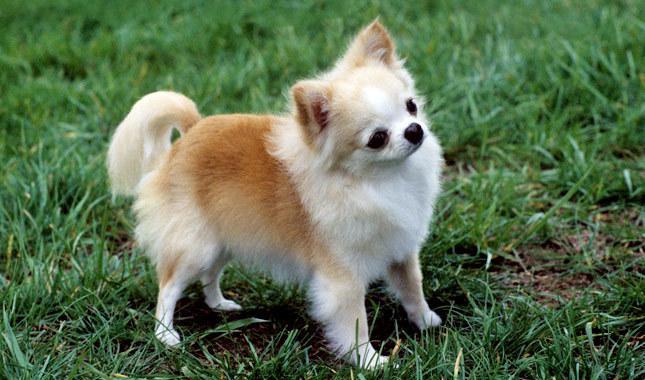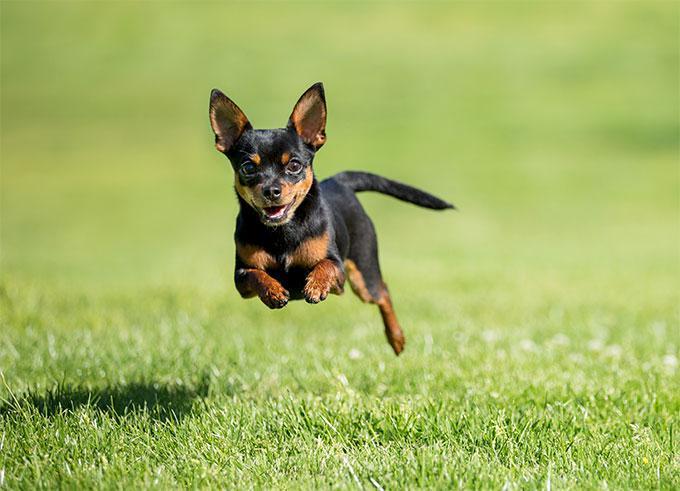The first image is the image on the left, the second image is the image on the right. Assess this claim about the two images: "the dog on the right image has its mouth open". Correct or not? Answer yes or no. Yes. 